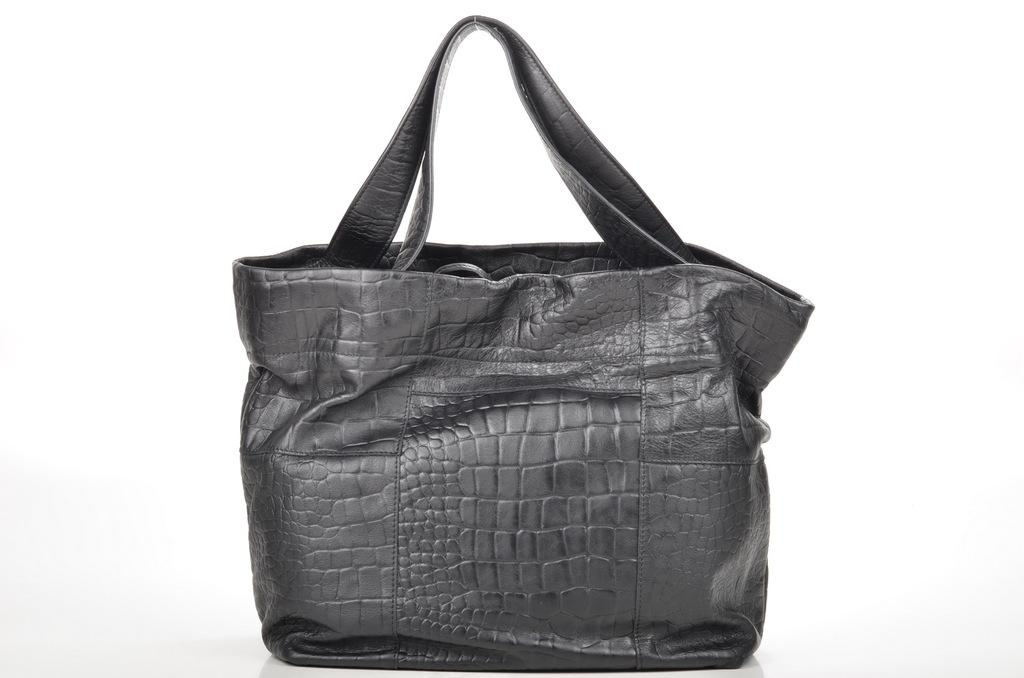What type of accessory is visible in the image? There is a woman's handbag in the image. Can you describe the handbag in more detail? Unfortunately, the image only shows the handbag, and no further details are available. What type of treatment does the clover receive in the image? There is no clover present in the image, so it is not possible to determine any treatment it might receive. 